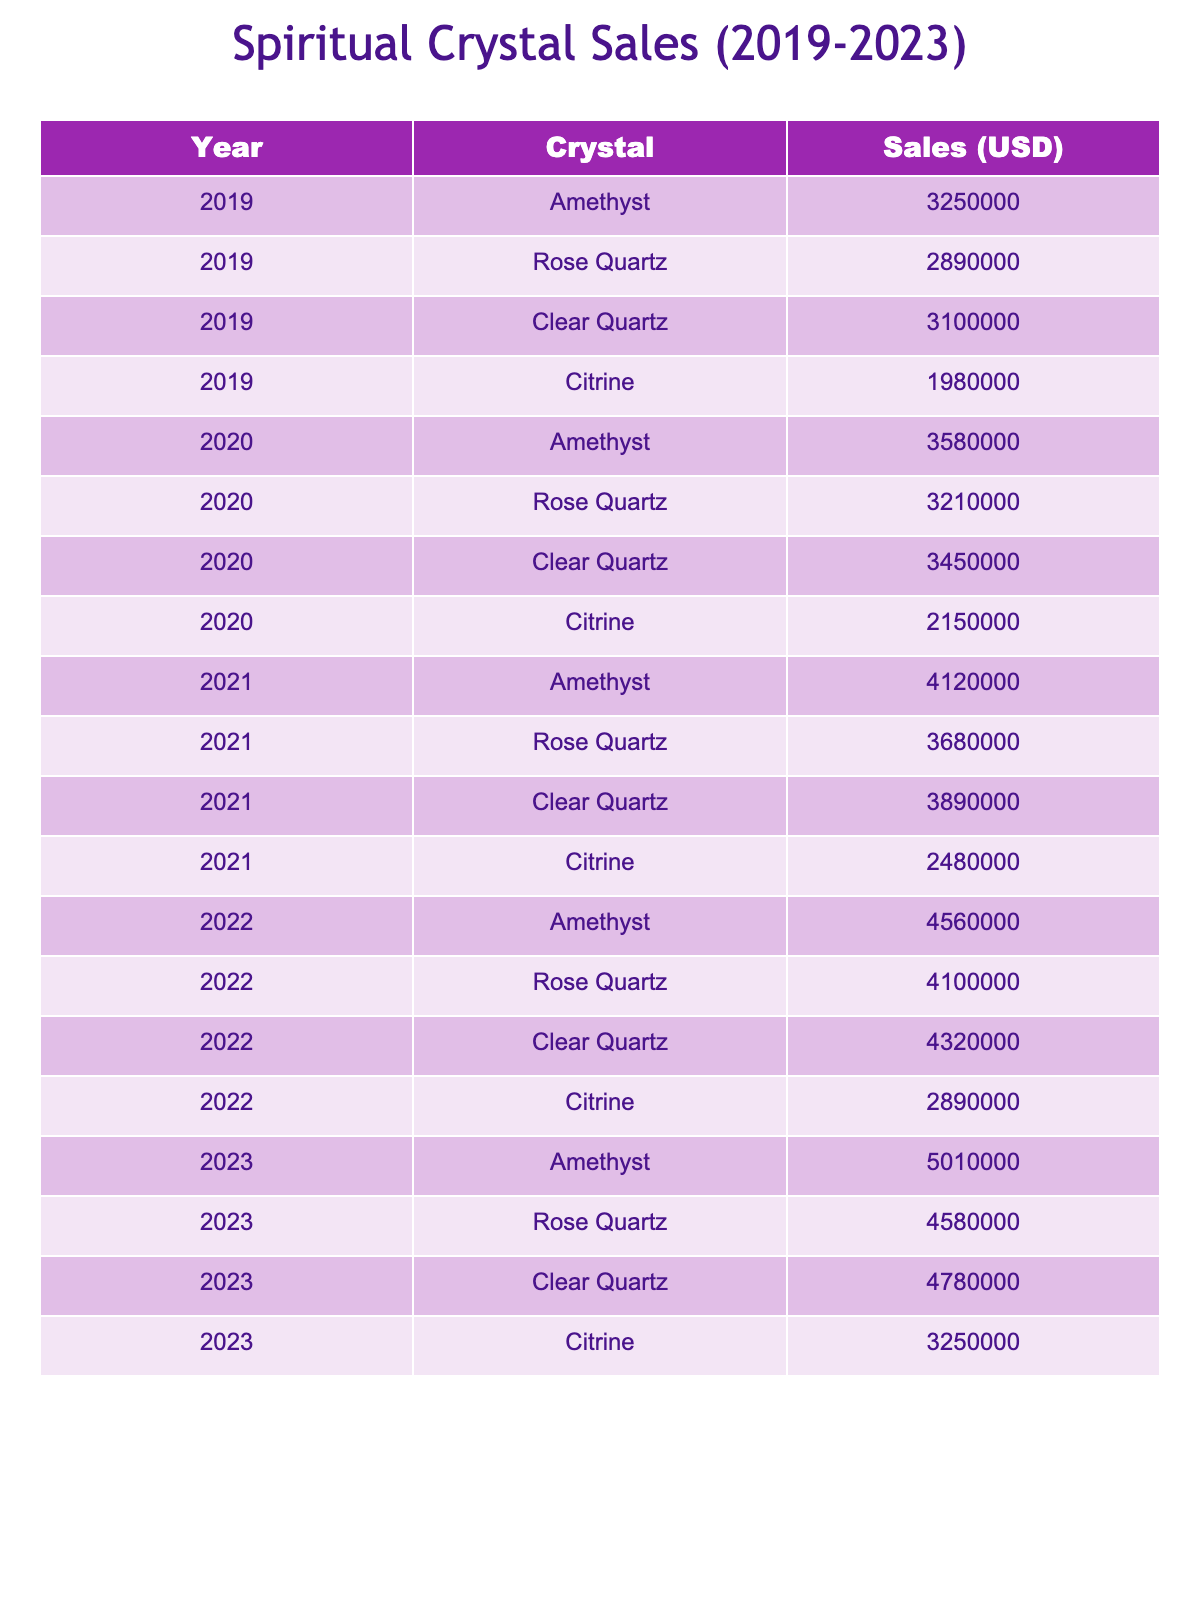What's the highest sales amount for Rose Quartz in any year? The highest sales amount for Rose Quartz can be found by looking at the sales figures for each year. In 2023, the sales amount is 4,580,000 USD, which is the highest listed in the table for this crystal.
Answer: 4,580,000 USD How much did sales of Clear Quartz increase from 2019 to 2023? To find the increase, subtract the 2019 sales amount (3,100,000 USD) from the 2023 sales amount (4,780,000 USD). Thus, the increase is 4,780,000 - 3,100,000 = 1,680,000 USD.
Answer: 1,680,000 USD What was the total sales amount for Citrine from 2019 to 2022? The total sales amount for Citrine can be calculated by adding the sales amounts from each year: 1,980,000 (2019) + 2,150,000 (2020) + 2,480,000 (2021) + 2,890,000 (2022) = 9,500,000 USD.
Answer: 9,500,000 USD Which crystal had the lowest total sales over the five years and what was that total? First, we need to sum the sales for each crystal over all years: Amethyst (4,725,000), Rose Quartz (4,865,000), Clear Quartz (5,085,000), and Citrine (10,050,000). Among them, Amethyst has the lowest total sales of 4,725,000 USD.
Answer: Amethyst, 4,725,000 USD Did the sales of Amethyst ever dip below 3 million USD in any year? By looking at the sales figures presented, Amethyst sales were 3,250,000 USD in 2019 and increased every subsequent year. Thus, Amethyst sales never dipped below 3 million USD.
Answer: No What was the average annual sales for Clear Quartz over the five years? To find the average, sum the sales amounts for Clear Quartz (3,100,000 + 3,450,000 + 3,890,000 + 4,320,000 + 4,780,000 = 19,530,000) and divide by the number of years (5). Thus, the average sales amount is 19,530,000 / 5 = 3,906,000 USD.
Answer: 3,906,000 USD In which year did Citrine have its lowest sales, and how much was it? By examining the sales figures for Citrine, we see the values for each year are 1,980,000 (2019), 2,150,000 (2020), 2,480,000 (2021), 2,890,000 (2022), and 3,250,000 (2023). The lowest sales occurred in 2019 at 1,980,000 USD.
Answer: 2019, 1,980,000 USD Which crystal showed the highest growth in sales from 2019 to 2023? To determine this, calculate the growth for each crystal: Amethyst (5,010,000 - 3,250,000 = 1,760,000), Rose Quartz (4,580,000 - 2,890,000 = 1,690,000), Clear Quartz (4,780,000 - 3,100,000 = 1,680,000), Citrine (3,250,000 - 1,980,000 = 1,270,000). Amethyst has the highest growth of 1,760,000 USD.
Answer: Amethyst, 1,760,000 USD What percentage of total sales from 2023 does Rose Quartz represent? First, sum the total sales from 2023: 5,010,000 (Amethyst) + 4,580,000 (Rose Quartz) + 4,780,000 (Clear Quartz) + 3,250,000 (Citrine) = 17,620,000 USD. To find the percentage of sales for Rose Quartz: (4,580,000 / 17,620,000) * 100 ≈ 25.94%.
Answer: Approximately 25.94% 